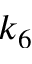Convert formula to latex. <formula><loc_0><loc_0><loc_500><loc_500>k _ { 6 }</formula> 